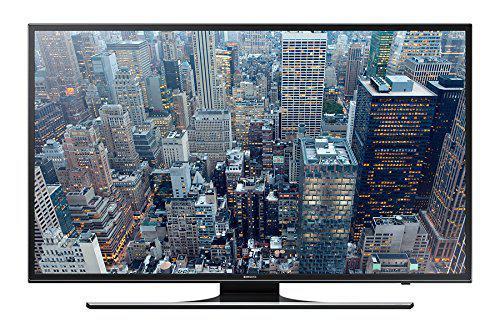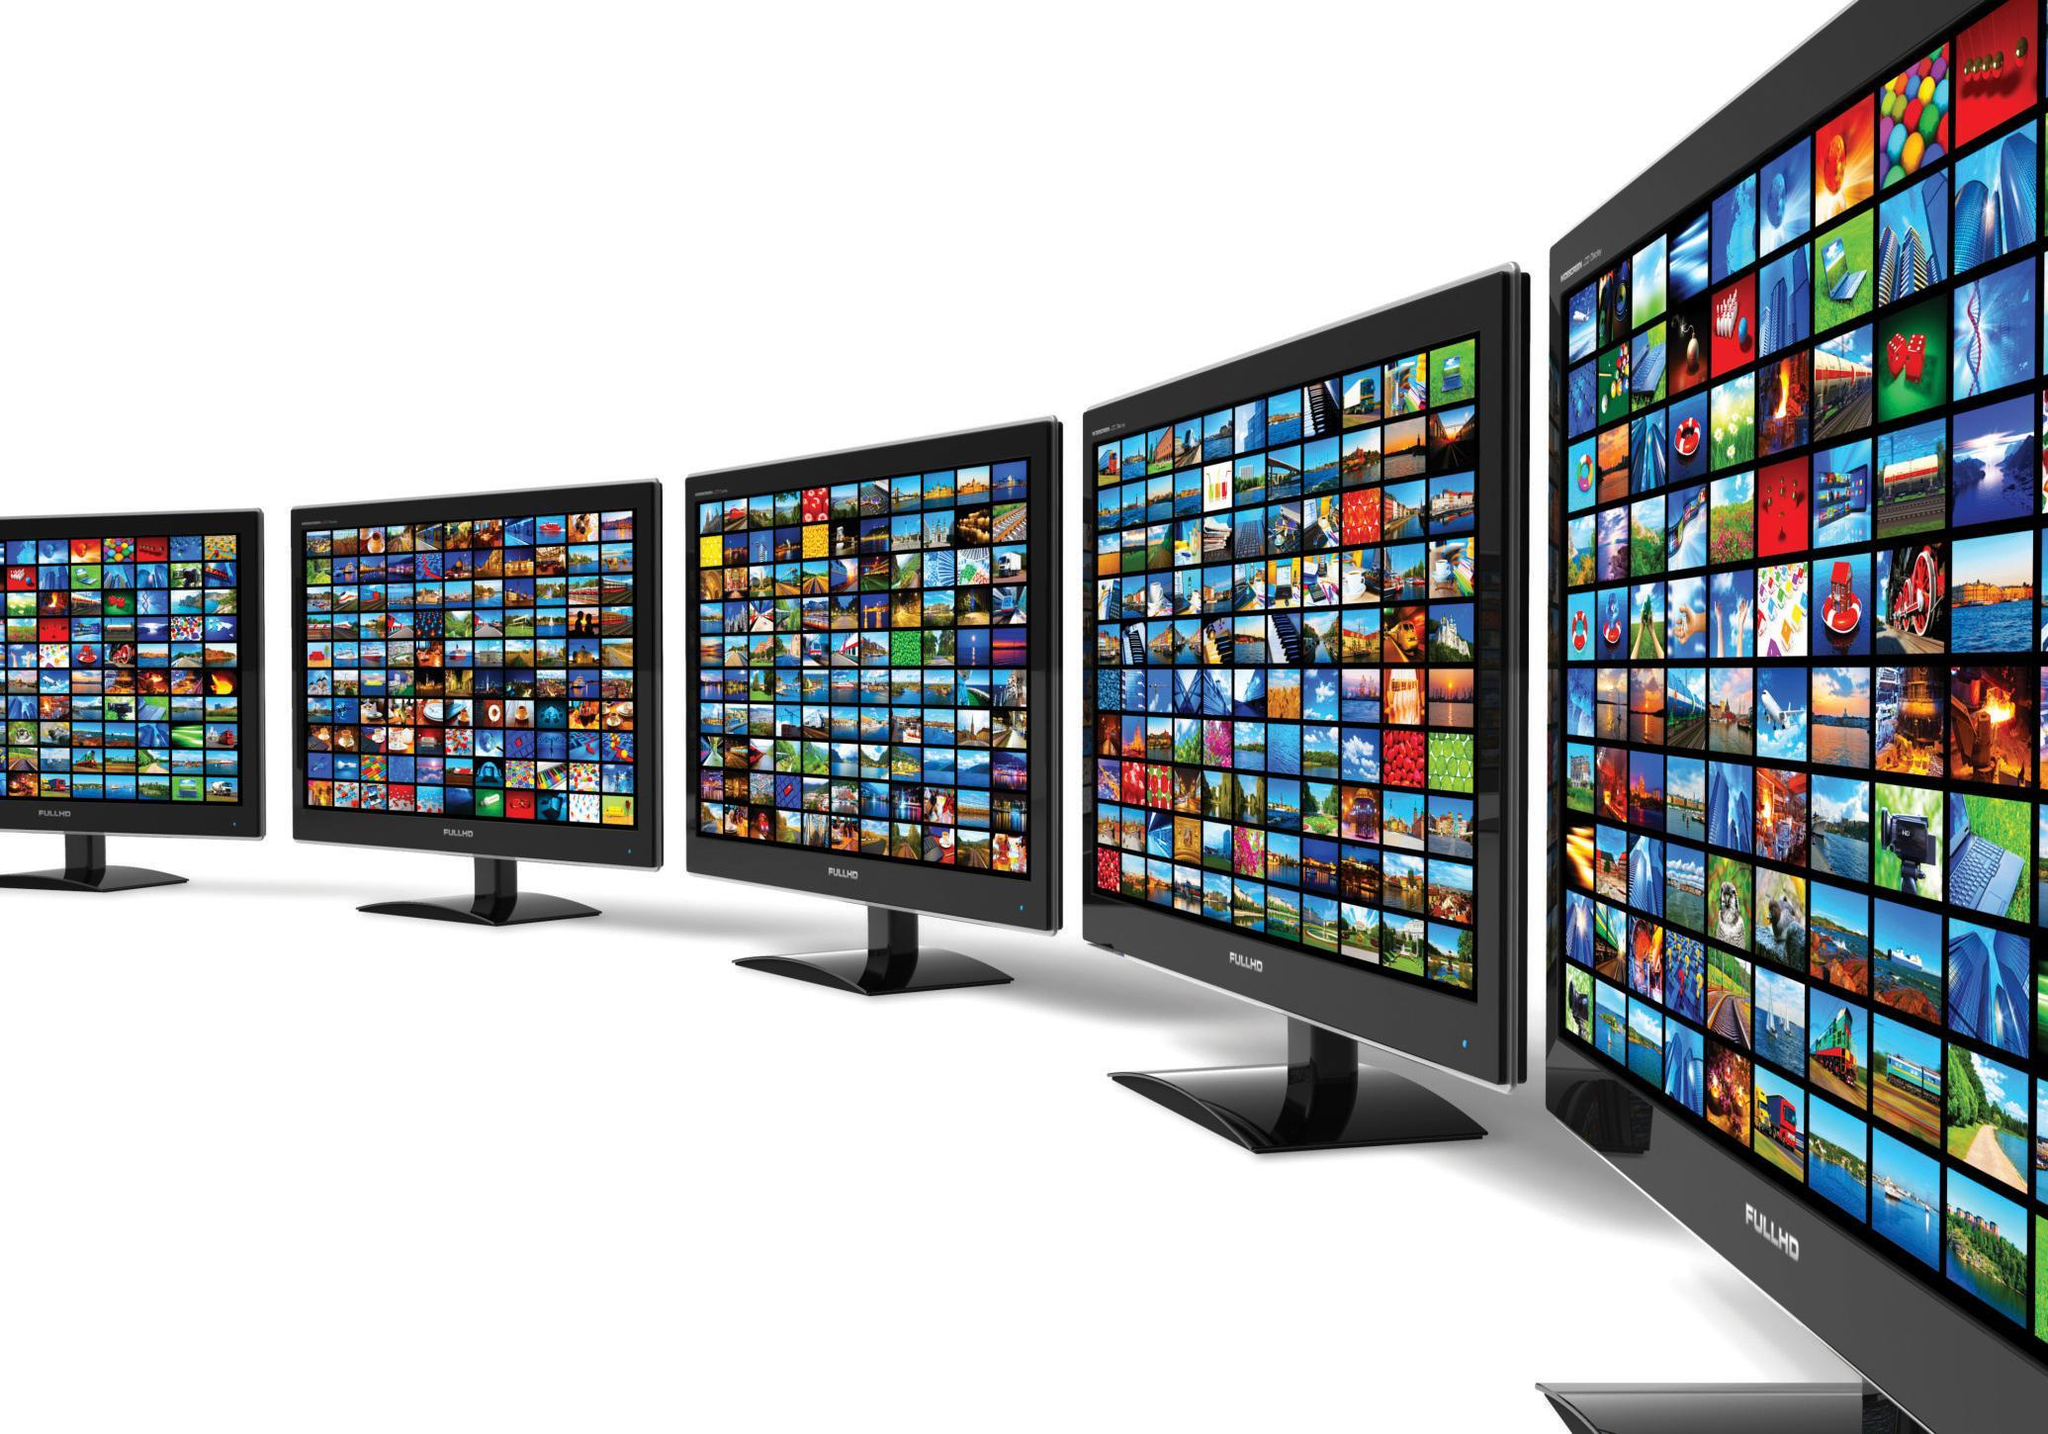The first image is the image on the left, the second image is the image on the right. For the images shown, is this caption "Each image shows a single flat screen TV, and at least one image features an aerial city view on the screen." true? Answer yes or no. No. 